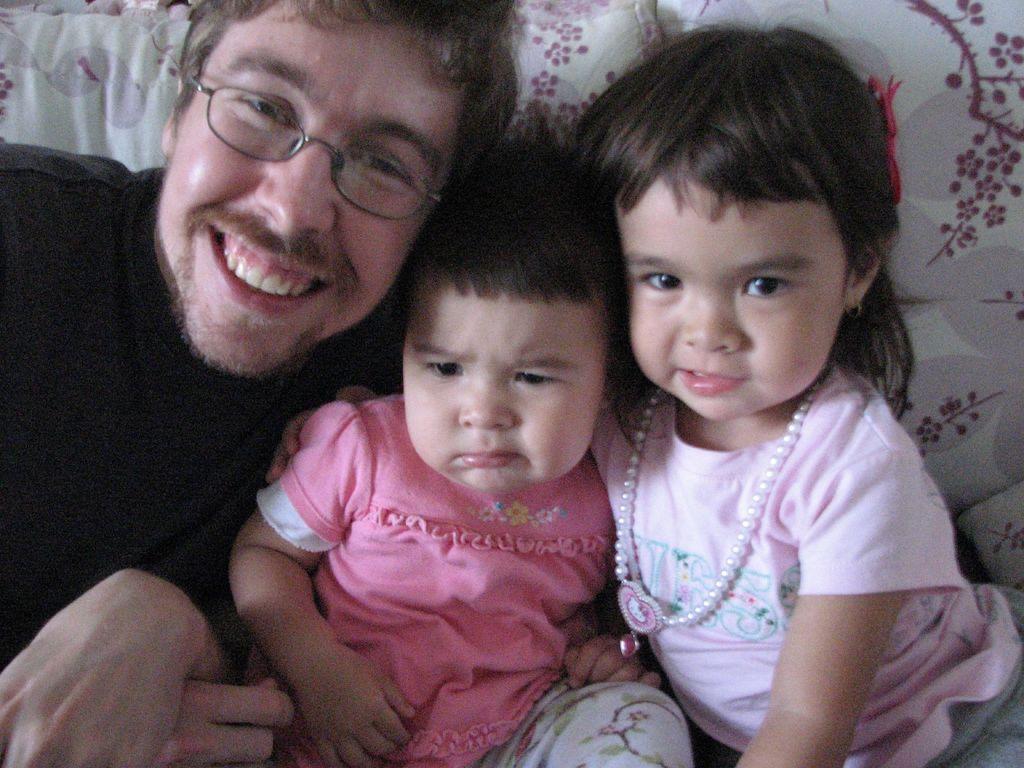Describe this image in one or two sentences. In this picture we can see there are three people sitting on a couch and a man with the spectacles is smiling. 